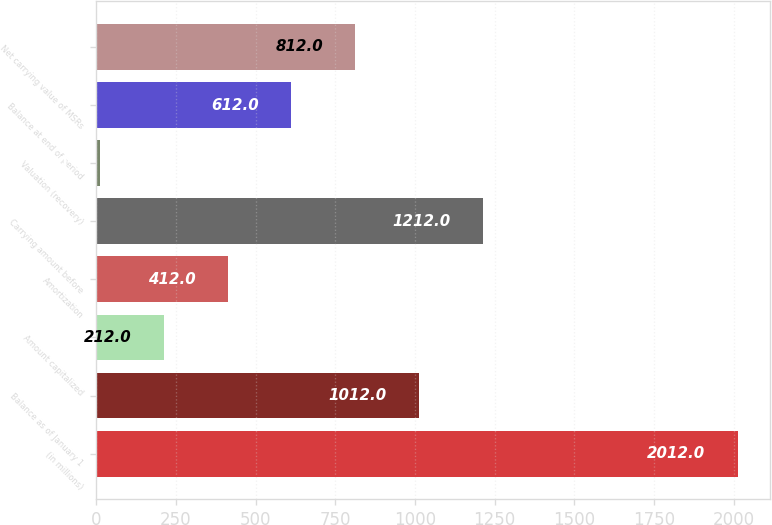<chart> <loc_0><loc_0><loc_500><loc_500><bar_chart><fcel>(in millions)<fcel>Balance as of January 1<fcel>Amount capitalized<fcel>Amortization<fcel>Carrying amount before<fcel>Valuation (recovery)<fcel>Balance at end of period<fcel>Net carrying value of MSRs<nl><fcel>2012<fcel>1012<fcel>212<fcel>412<fcel>1212<fcel>12<fcel>612<fcel>812<nl></chart> 